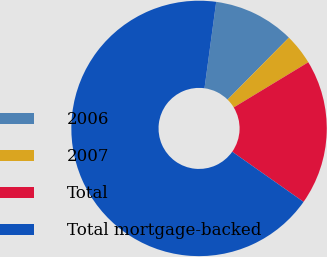Convert chart. <chart><loc_0><loc_0><loc_500><loc_500><pie_chart><fcel>2006<fcel>2007<fcel>Total<fcel>Total mortgage-backed<nl><fcel>10.27%<fcel>3.92%<fcel>18.42%<fcel>67.39%<nl></chart> 